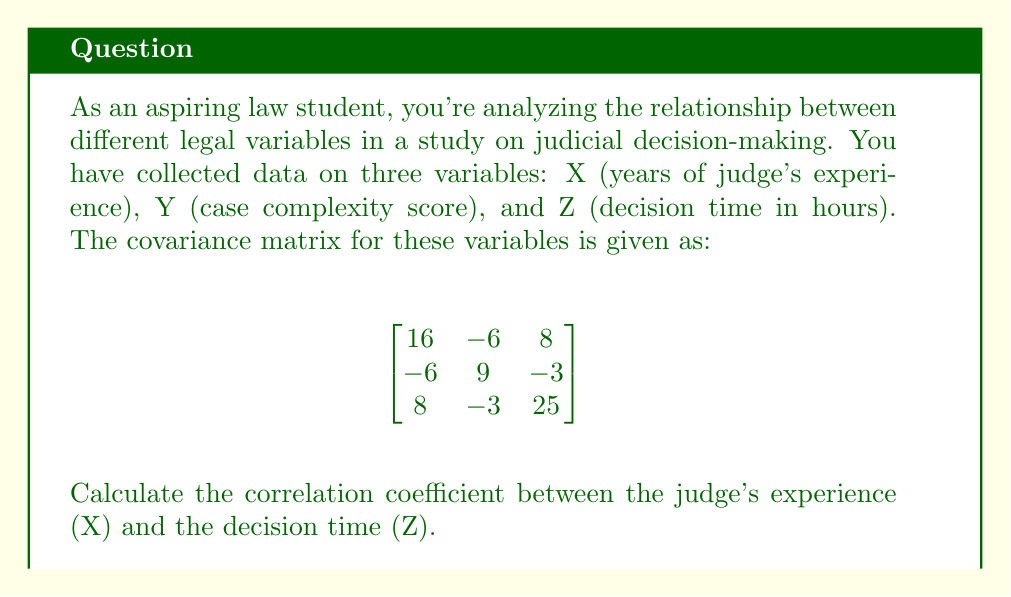Can you solve this math problem? To calculate the correlation coefficient between variables X and Z, we'll use the formula:

$$ r_{XZ} = \frac{Cov(X,Z)}{\sqrt{Var(X) \cdot Var(Z)}} $$

Where:
- $Cov(X,Z)$ is the covariance between X and Z
- $Var(X)$ is the variance of X
- $Var(Z)$ is the variance of Z

Step 1: Identify the required values from the covariance matrix:
- $Cov(X,Z) = 8$ (element in row 1, column 3)
- $Var(X) = 16$ (element in row 1, column 1)
- $Var(Z) = 25$ (element in row 3, column 3)

Step 2: Substitute these values into the correlation coefficient formula:

$$ r_{XZ} = \frac{8}{\sqrt{16 \cdot 25}} $$

Step 3: Simplify:
$$ r_{XZ} = \frac{8}{\sqrt{400}} = \frac{8}{20} = 0.4 $$

Therefore, the correlation coefficient between the judge's experience (X) and the decision time (Z) is 0.4.
Answer: 0.4 